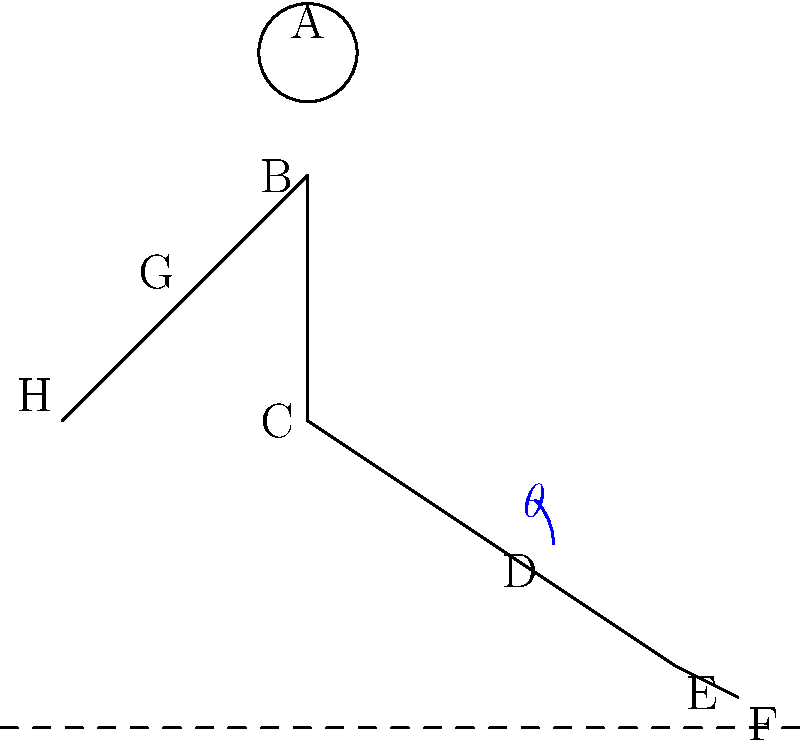In the stick figure illustration of a sliding tackle, what is the significance of the angle $\theta$ at point D (knee) in terms of maintaining balance and maximizing the effectiveness of the tackle? To understand the significance of angle $\theta$ at point D (knee) during a sliding tackle, let's break it down step-by-step:

1. Body positioning: The stick figure shows a player in a sliding tackle position, with the body leaning forward and one leg extended.

2. Center of gravity: The bent knee (point D) helps lower the player's center of gravity, which is crucial for stability during the tackle.

3. Angle $\theta$: This angle represents the flexion of the knee joint. It's critical because:
   a) It allows for shock absorption upon impact with the ground or the ball.
   b) It provides control over the sliding motion.

4. Balance: The angle $\theta$ affects the distribution of the player's weight between points D (knee) and E (ankle). A smaller angle concentrates more weight on the knee, while a larger angle shifts weight towards the ankle.

5. Surface area: The angle influences the surface area of the leg in contact with the ground. A more acute angle increases this area, providing better stability and control during the slide.

6. Tackle effectiveness: The optimal angle allows the player to:
   a) Maximize reach to get to the ball.
   b) Maintain enough control to direct the ball after contact.
   c) Minimize the risk of injury from overextension.

7. Adaptability: Being able to adjust this angle quickly allows the player to react to changes in the opponent's movement or ball direction.

8. Recovery: The angle $\theta$ also plays a role in how quickly the player can recover and get back on their feet after the tackle.

In soccer biomechanics, an angle $\theta$ between 30° and 45° is often considered optimal, balancing reach, control, and safety. However, the exact angle may vary based on the specific situation and the player's physical attributes.
Answer: Angle $\theta$ optimizes balance, control, and effectiveness in a sliding tackle by lowering the center of gravity, providing shock absorption, and allowing adaptability in a 30°-45° range. 